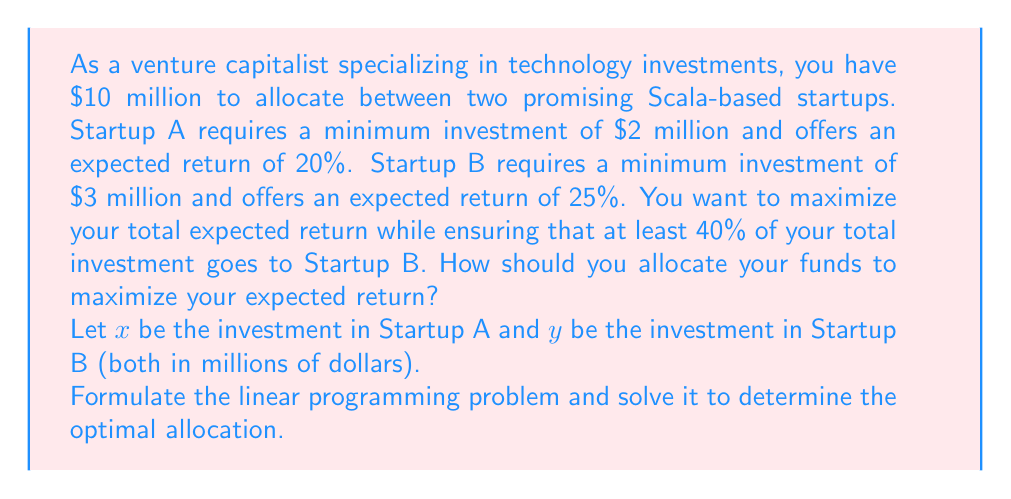Help me with this question. Let's approach this step-by-step:

1) Define the objective function:
   We want to maximize the total expected return.
   $$\text{Maximize: } 0.20x + 0.25y$$

2) Define the constraints:
   a) Total investment constraint: $x + y \leq 10$
   b) Minimum investment for A: $x \geq 2$
   c) Minimum investment for B: $y \geq 3$
   d) At least 40% in B: $y \geq 0.4(x + y)$ or $0.6y \geq 0.4x$

3) Simplify the last constraint:
   $0.6y \geq 0.4x$
   $3y \geq 2x$

4) Our complete linear programming problem:
   $$\text{Maximize: } 0.20x + 0.25y$$
   Subject to:
   $$x + y \leq 10$$
   $$x \geq 2$$
   $$y \geq 3$$
   $$3y \geq 2x$$
   $$x, y \geq 0$$

5) To solve this, we can use the corner point method. The feasible region is bounded by these constraints, and the optimal solution will be at one of the corners.

6) The corners of our feasible region are:
   (2, 8), (4, 6), and (3.6, 6.4)

7) Evaluating our objective function at each point:
   (2, 8): $0.20(2) + 0.25(8) = 2.4$
   (4, 6): $0.20(4) + 0.25(6) = 2.3$
   (3.6, 6.4): $0.20(3.6) + 0.25(6.4) = 2.32$

8) The maximum value occurs at (2, 8).

Therefore, the optimal allocation is to invest $2 million in Startup A and $8 million in Startup B.
Answer: $2 million in Startup A, $8 million in Startup B 